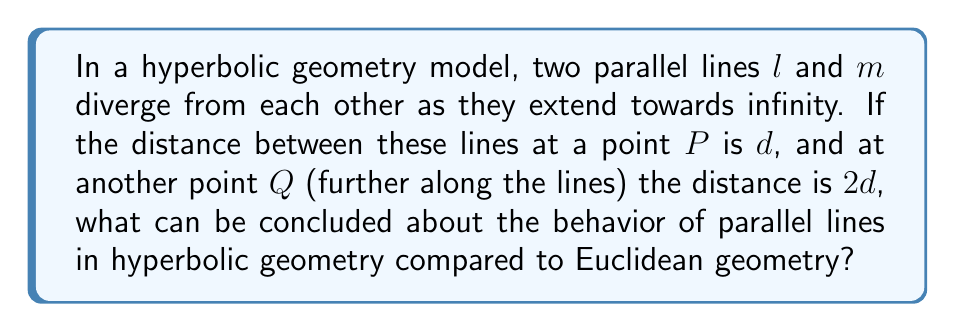Can you solve this math problem? Let's approach this step-by-step:

1) In Euclidean geometry:
   - Parallel lines maintain a constant distance from each other.
   - If $l$ and $m$ were Euclidean parallel lines, the distance between them would remain $d$ at all points.

2) In hyperbolic geometry:
   - The given information states that the distance between $l$ and $m$ increases from $d$ to $2d$.
   - This divergence is a key property of parallel lines in hyperbolic geometry.

3) Comparison:
   - Euclidean parallel lines: $d_{Euclidean}(l,m) = \text{constant}$
   - Hyperbolic parallel lines: $d_{Hyperbolic}(l,m) \text{ increases with distance}$

4) Visualization:
   [asy]
   import geometry;
   
   size(200);
   
   path hyp_l = (0,0)..(100,20);
   path hyp_m = (0,10)..(100,50);
   
   draw(hyp_l, blue);
   draw(hyp_m, blue);
   
   label("$l$", hyp_l, S);
   label("$m$", hyp_m, N);
   
   dot("$P$", (20,5));
   dot("$Q$", (80,30));
   
   draw((20,5)--(20,15), red, Arrow);
   draw((80,30)--(80,50), red, Arrow);
   
   label("$d$", (22,10), E);
   label("$2d$", (82,40), E);
   [/asy]

5) Conclusion:
   - In hyperbolic geometry, parallel lines exhibit a fundamental property of divergence.
   - This divergence contradicts the Euclidean parallel postulate, which states that parallel lines maintain a constant distance.
Answer: Parallel lines diverge in hyperbolic geometry, while they remain equidistant in Euclidean geometry. 